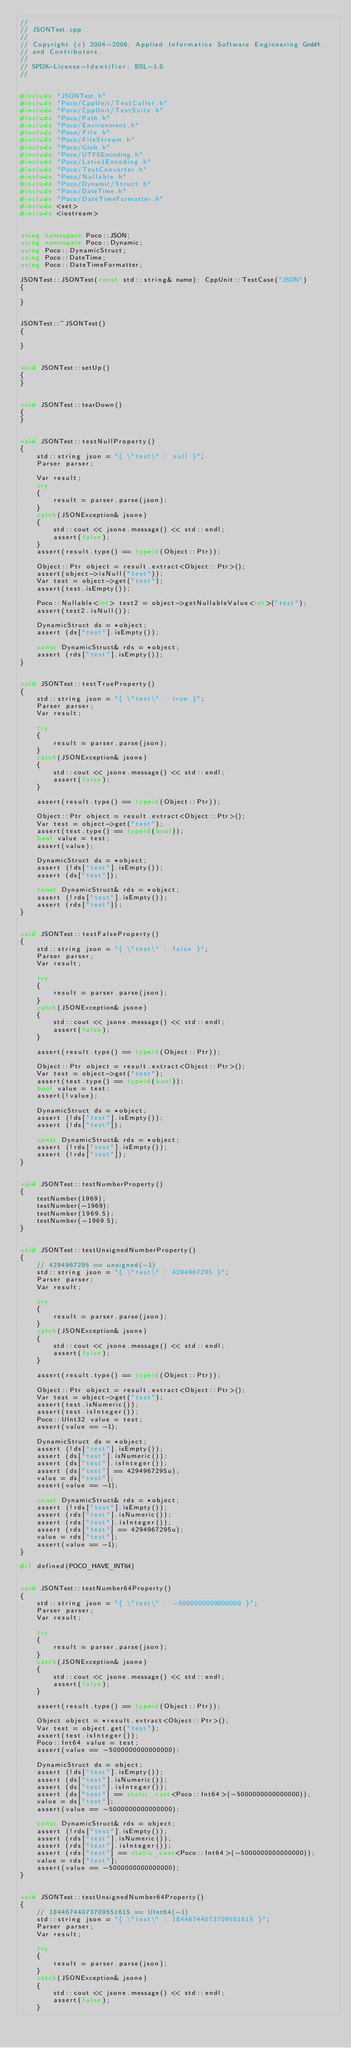Convert code to text. <code><loc_0><loc_0><loc_500><loc_500><_C++_>//
// JSONTest.cpp
//
// Copyright (c) 2004-2006, Applied Informatics Software Engineering GmbH.
// and Contributors.
//
// SPDX-License-Identifier:	BSL-1.0
//


#include "JSONTest.h"
#include "Poco/CppUnit/TestCaller.h"
#include "Poco/CppUnit/TestSuite.h"
#include "Poco/Path.h"
#include "Poco/Environment.h"
#include "Poco/File.h"
#include "Poco/FileStream.h"
#include "Poco/Glob.h"
#include "Poco/UTF8Encoding.h"
#include "Poco/Latin1Encoding.h"
#include "Poco/TextConverter.h"
#include "Poco/Nullable.h"
#include "Poco/Dynamic/Struct.h"
#include "Poco/DateTime.h"
#include "Poco/DateTimeFormatter.h"
#include <set>
#include <iostream>


using namespace Poco::JSON;
using namespace Poco::Dynamic;
using Poco::DynamicStruct;
using Poco::DateTime;
using Poco::DateTimeFormatter;

JSONTest::JSONTest(const std::string& name): CppUnit::TestCase("JSON")
{

}


JSONTest::~JSONTest()
{

}


void JSONTest::setUp()
{
}


void JSONTest::tearDown()
{
}


void JSONTest::testNullProperty()
{
	std::string json = "{ \"test\" : null }";
	Parser parser;

	Var result;
	try
	{
		result = parser.parse(json);
	}
	catch(JSONException& jsone)
	{
		std::cout << jsone.message() << std::endl;
		assert(false);
	}
	assert(result.type() == typeid(Object::Ptr));

	Object::Ptr object = result.extract<Object::Ptr>();
	assert(object->isNull("test"));
	Var test = object->get("test");
	assert(test.isEmpty());

	Poco::Nullable<int> test2 = object->getNullableValue<int>("test");
	assert(test2.isNull());

	DynamicStruct ds = *object;
	assert (ds["test"].isEmpty());

	const DynamicStruct& rds = *object;
	assert (rds["test"].isEmpty());
}


void JSONTest::testTrueProperty()
{
	std::string json = "{ \"test\" : true }";
	Parser parser;
	Var result;

	try
	{
		result = parser.parse(json);
	}
	catch(JSONException& jsone)
	{
		std::cout << jsone.message() << std::endl;
		assert(false);
	}

	assert(result.type() == typeid(Object::Ptr));

	Object::Ptr object = result.extract<Object::Ptr>();
	Var test = object->get("test");
	assert(test.type() == typeid(bool));
	bool value = test;
	assert(value);

	DynamicStruct ds = *object;
	assert (!ds["test"].isEmpty());
	assert (ds["test"]);

	const DynamicStruct& rds = *object;
	assert (!rds["test"].isEmpty());
	assert (rds["test"]);
}


void JSONTest::testFalseProperty()
{
	std::string json = "{ \"test\" : false }";
	Parser parser;
	Var result;

	try
	{
		result = parser.parse(json);
	}
	catch(JSONException& jsone)
	{
		std::cout << jsone.message() << std::endl;
		assert(false);
	}

	assert(result.type() == typeid(Object::Ptr));

	Object::Ptr object = result.extract<Object::Ptr>();
	Var test = object->get("test");
	assert(test.type() == typeid(bool));
	bool value = test;
	assert(!value);

	DynamicStruct ds = *object;
	assert (!ds["test"].isEmpty());
	assert (!ds["test"]);

	const DynamicStruct& rds = *object;
	assert (!rds["test"].isEmpty());
	assert (!rds["test"]);
}


void JSONTest::testNumberProperty()
{
	testNumber(1969);
	testNumber(-1969);
	testNumber(1969.5);
	testNumber(-1969.5);
}


void JSONTest::testUnsignedNumberProperty()
{
	// 4294967295 == unsigned(-1)
	std::string json = "{ \"test\" : 4294967295 }";
	Parser parser;
	Var result;

	try
	{
		result = parser.parse(json);
	}
	catch(JSONException& jsone)
	{
		std::cout << jsone.message() << std::endl;
		assert(false);
	}

	assert(result.type() == typeid(Object::Ptr));

	Object::Ptr object = result.extract<Object::Ptr>();
	Var test = object->get("test");
	assert(test.isNumeric());
	assert(test.isInteger());
	Poco::UInt32 value = test;
	assert(value == -1);

	DynamicStruct ds = *object;
	assert (!ds["test"].isEmpty());
	assert (ds["test"].isNumeric());
	assert (ds["test"].isInteger());
	assert (ds["test"] == 4294967295u);
	value = ds["test"];
	assert(value == -1);

	const DynamicStruct& rds = *object;
	assert (!rds["test"].isEmpty());
	assert (rds["test"].isNumeric());
	assert (rds["test"].isInteger());
	assert (rds["test"] == 4294967295u);
	value = rds["test"];
	assert(value == -1);
}

#if defined(POCO_HAVE_INT64)


void JSONTest::testNumber64Property()
{
	std::string json = "{ \"test\" : -5000000000000000 }";
	Parser parser;
	Var result;

	try
	{
		result = parser.parse(json);
	}
	catch(JSONException& jsone)
	{
		std::cout << jsone.message() << std::endl;
		assert(false);
	}

	assert(result.type() == typeid(Object::Ptr));

	Object object = *result.extract<Object::Ptr>();
	Var test = object.get("test");
	assert(test.isInteger());
	Poco::Int64 value = test;
	assert(value == -5000000000000000);

	DynamicStruct ds = object;
	assert (!ds["test"].isEmpty());
	assert (ds["test"].isNumeric());
	assert (ds["test"].isInteger());
	assert (ds["test"] == static_cast<Poco::Int64>(-5000000000000000));
	value = ds["test"];
	assert(value == -5000000000000000);

	const DynamicStruct& rds = object;
	assert (!rds["test"].isEmpty());
	assert (rds["test"].isNumeric());
	assert (rds["test"].isInteger());
	assert (rds["test"] == static_cast<Poco::Int64>(-5000000000000000));
	value = rds["test"];
	assert(value == -5000000000000000);
}


void JSONTest::testUnsignedNumber64Property()
{
	// 18446744073709551615 == UInt64(-1)
	std::string json = "{ \"test\" : 18446744073709551615 }";
	Parser parser;
	Var result;

	try
	{
		result = parser.parse(json);
	}
	catch(JSONException& jsone)
	{
		std::cout << jsone.message() << std::endl;
		assert(false);
	}
</code> 